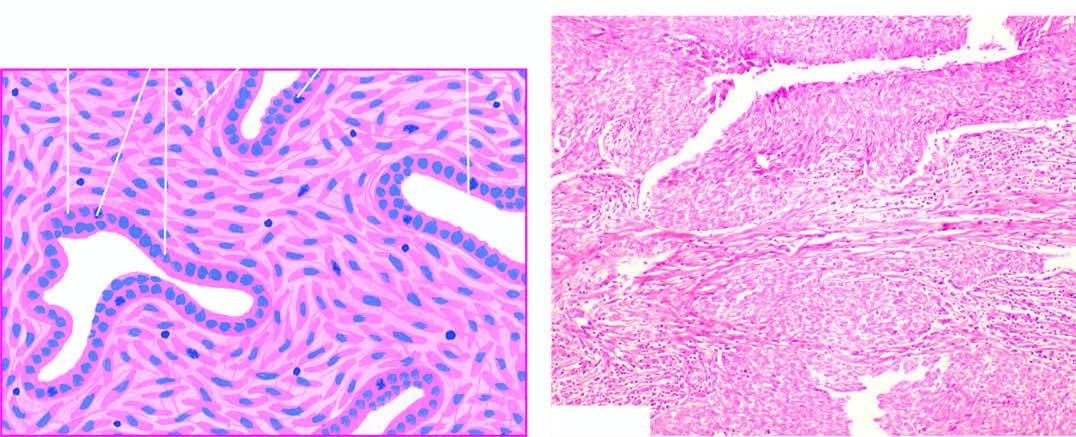s stroma composed of epithelial-like cells lining cleft-like spaces and gland-like structures?
Answer the question using a single word or phrase. No 